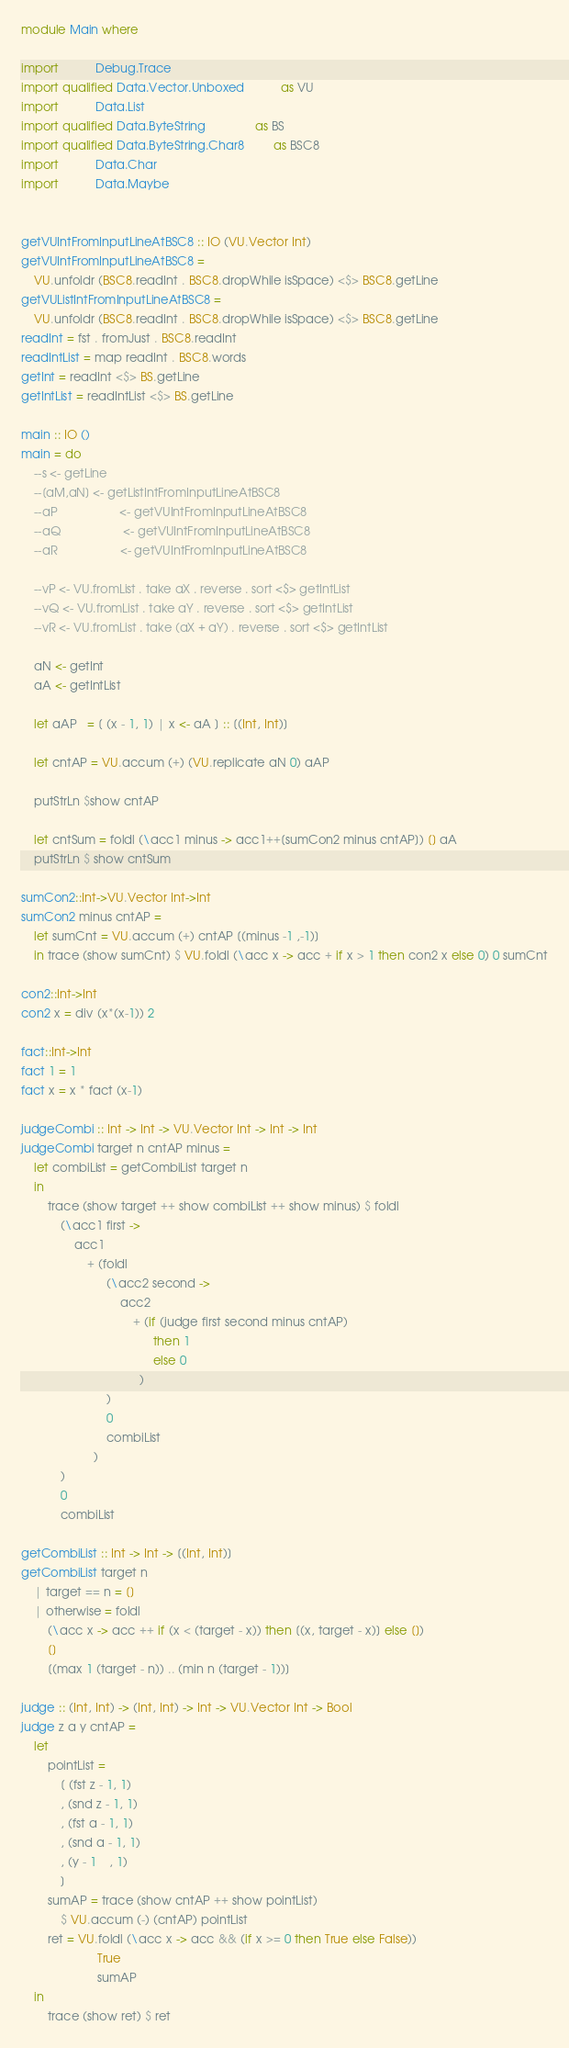Convert code to text. <code><loc_0><loc_0><loc_500><loc_500><_Haskell_>module Main where

import           Debug.Trace
import qualified Data.Vector.Unboxed           as VU
import           Data.List
import qualified Data.ByteString               as BS
import qualified Data.ByteString.Char8         as BSC8
import           Data.Char
import           Data.Maybe


getVUIntFromInputLineAtBSC8 :: IO (VU.Vector Int)
getVUIntFromInputLineAtBSC8 =
    VU.unfoldr (BSC8.readInt . BSC8.dropWhile isSpace) <$> BSC8.getLine
getVUListIntFromInputLineAtBSC8 =
    VU.unfoldr (BSC8.readInt . BSC8.dropWhile isSpace) <$> BSC8.getLine
readInt = fst . fromJust . BSC8.readInt
readIntList = map readInt . BSC8.words
getInt = readInt <$> BS.getLine
getIntList = readIntList <$> BS.getLine

main :: IO ()
main = do
    --s <- getLine
    --[aM,aN] <- getListIntFromInputLineAtBSC8
    --aP                   <- getVUIntFromInputLineAtBSC8
    --aQ                   <- getVUIntFromInputLineAtBSC8
    --aR                   <- getVUIntFromInputLineAtBSC8

    --vP <- VU.fromList . take aX . reverse . sort <$> getIntList
    --vQ <- VU.fromList . take aY . reverse . sort <$> getIntList
    --vR <- VU.fromList . take (aX + aY) . reverse . sort <$> getIntList

    aN <- getInt
    aA <- getIntList

    let aAP   = [ (x - 1, 1) | x <- aA ] :: [(Int, Int)]

    let cntAP = VU.accum (+) (VU.replicate aN 0) aAP

    putStrLn $show cntAP

    let cntSum = foldl (\acc1 minus -> acc1++[sumCon2 minus cntAP]) [] aA
    putStrLn $ show cntSum

sumCon2::Int->VU.Vector Int->Int
sumCon2 minus cntAP =
    let sumCnt = VU.accum (+) cntAP [(minus -1 ,-1)]
    in trace (show sumCnt) $ VU.foldl (\acc x -> acc + if x > 1 then con2 x else 0) 0 sumCnt

con2::Int->Int
con2 x = div (x*(x-1)) 2   

fact::Int->Int
fact 1 = 1
fact x = x * fact (x-1)

judgeCombi :: Int -> Int -> VU.Vector Int -> Int -> Int
judgeCombi target n cntAP minus =
    let combiList = getCombiList target n
    in
        trace (show target ++ show combiList ++ show minus) $ foldl
            (\acc1 first ->
                acc1
                    + (foldl
                          (\acc2 second ->
                              acc2
                                  + (if (judge first second minus cntAP)
                                        then 1
                                        else 0
                                    )
                          )
                          0
                          combiList
                      )
            )
            0
            combiList

getCombiList :: Int -> Int -> [(Int, Int)]
getCombiList target n
    | target == n = []
    | otherwise = foldl
        (\acc x -> acc ++ if (x < (target - x)) then [(x, target - x)] else [])
        []
        [(max 1 (target - n)) .. (min n (target - 1))]

judge :: (Int, Int) -> (Int, Int) -> Int -> VU.Vector Int -> Bool
judge z a y cntAP =
    let
        pointList =
            [ (fst z - 1, 1)
            , (snd z - 1, 1)
            , (fst a - 1, 1)
            , (snd a - 1, 1)
            , (y - 1    , 1)
            ]
        sumAP = trace (show cntAP ++ show pointList)
            $ VU.accum (-) (cntAP) pointList
        ret = VU.foldl (\acc x -> acc && (if x >= 0 then True else False))
                       True
                       sumAP
    in
        trace (show ret) $ ret
</code> 